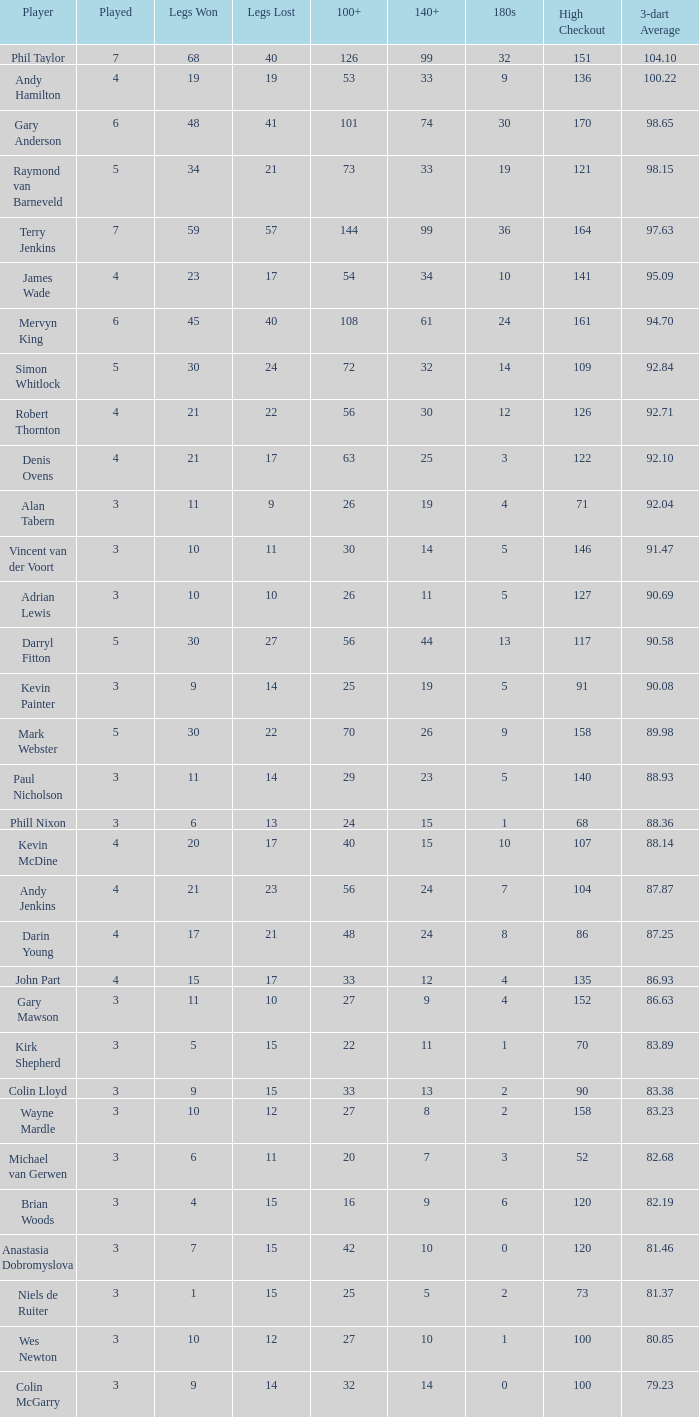What is the cumulative quantity of 3-dart average when legs lost is greater than 41, and played is more than 7? 0.0. 